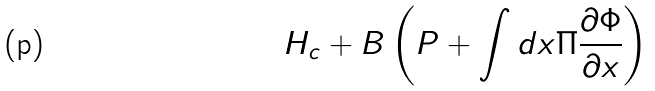Convert formula to latex. <formula><loc_0><loc_0><loc_500><loc_500>H _ { c } + B \left ( P + \int d x \Pi \frac { \partial \Phi } { \partial x } \right )</formula> 